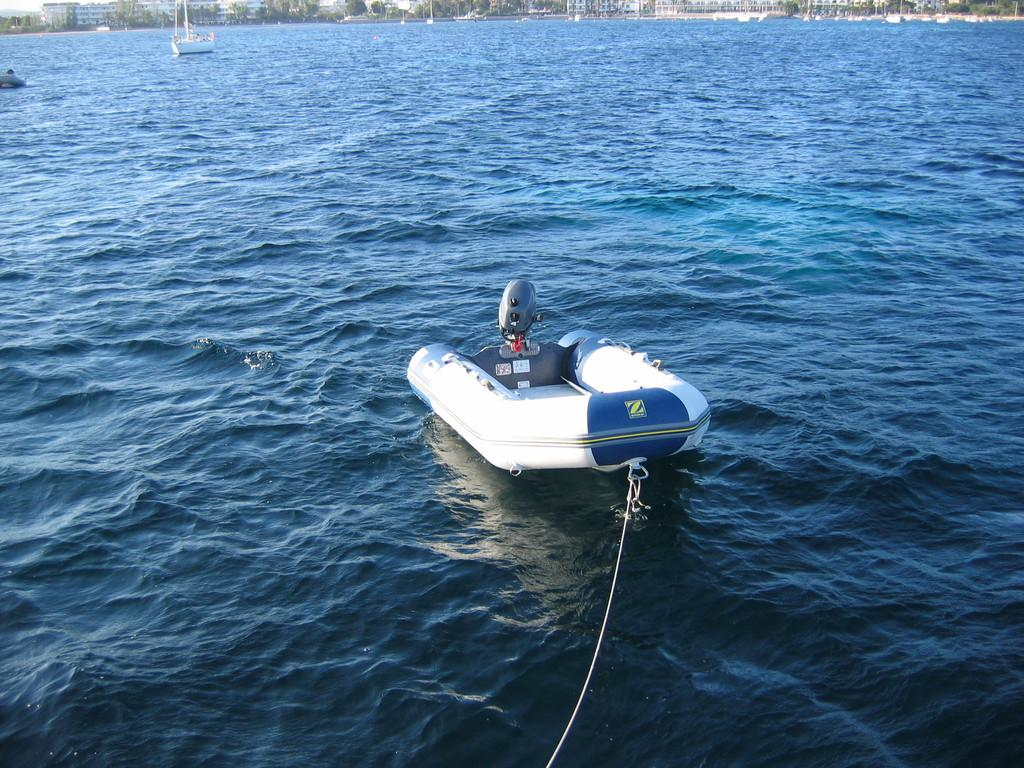<image>
Create a compact narrative representing the image presented. A blow up raft with a Z on the back of it is in the water. 